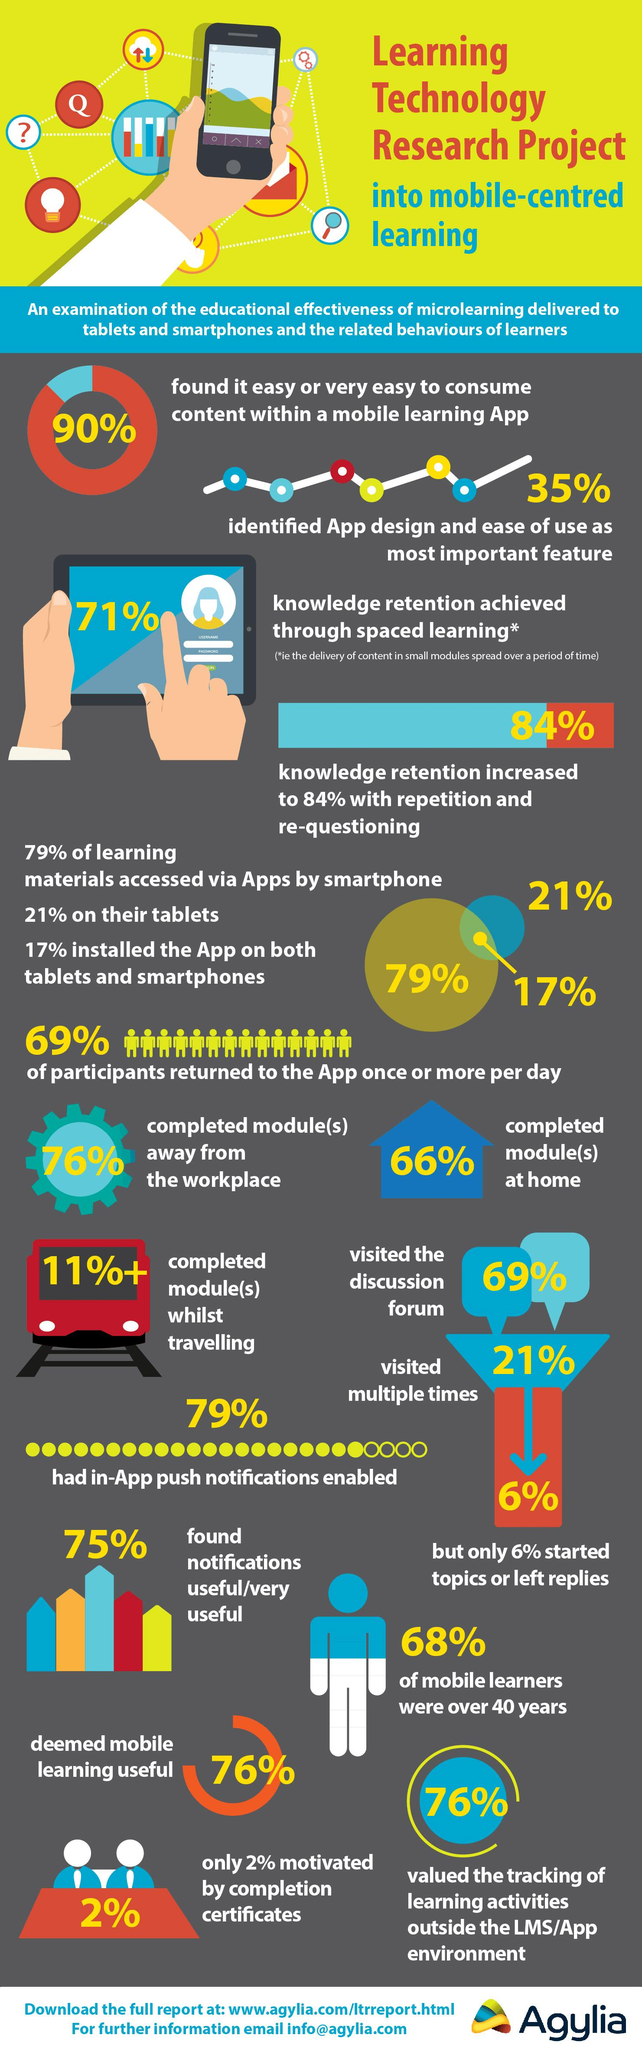Indicate a few pertinent items in this graphic. Studies have shown that spaced learning results in an average of 71% knowledge retention compared to traditional methods of learning. According to the data, approximately 32% of mobile learners were under the age of 40. According to the data, 79% of respondents have in-app push notifications enabled. According to the data, 62% of people used only apps on their smartphones. 10% of respondents found it difficult or very difficult to consume content within a mobile learning app. 